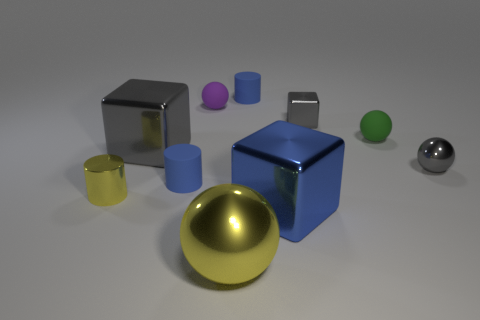Subtract all cylinders. How many objects are left? 7 Add 6 large shiny cubes. How many large shiny cubes exist? 8 Subtract 0 green blocks. How many objects are left? 10 Subtract all shiny balls. Subtract all tiny green matte things. How many objects are left? 7 Add 2 blue metal cubes. How many blue metal cubes are left? 3 